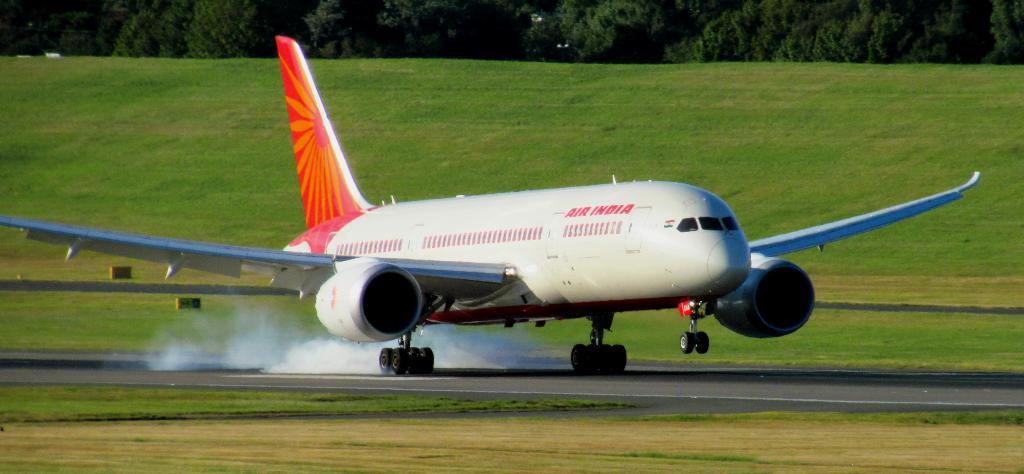What is the main subject of the image? The main subject of the image is an airplane. What else can be seen in the image besides the airplane? There is a road, smoke, grass, and trees visible in the image. Can you see the parent's shoes in the image? There is no parent or shoes present in the image. How does the grass touch the trees in the image? The grass does not touch the trees in the image; they are separate elements. 